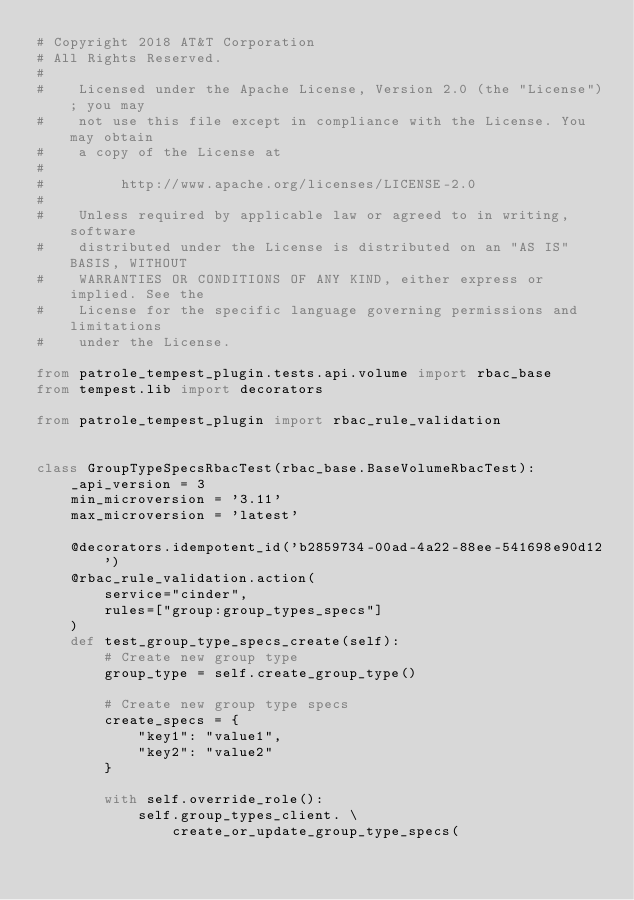Convert code to text. <code><loc_0><loc_0><loc_500><loc_500><_Python_># Copyright 2018 AT&T Corporation
# All Rights Reserved.
#
#    Licensed under the Apache License, Version 2.0 (the "License"); you may
#    not use this file except in compliance with the License. You may obtain
#    a copy of the License at
#
#         http://www.apache.org/licenses/LICENSE-2.0
#
#    Unless required by applicable law or agreed to in writing, software
#    distributed under the License is distributed on an "AS IS" BASIS, WITHOUT
#    WARRANTIES OR CONDITIONS OF ANY KIND, either express or implied. See the
#    License for the specific language governing permissions and limitations
#    under the License.

from patrole_tempest_plugin.tests.api.volume import rbac_base
from tempest.lib import decorators

from patrole_tempest_plugin import rbac_rule_validation


class GroupTypeSpecsRbacTest(rbac_base.BaseVolumeRbacTest):
    _api_version = 3
    min_microversion = '3.11'
    max_microversion = 'latest'

    @decorators.idempotent_id('b2859734-00ad-4a22-88ee-541698e90d12')
    @rbac_rule_validation.action(
        service="cinder",
        rules=["group:group_types_specs"]
    )
    def test_group_type_specs_create(self):
        # Create new group type
        group_type = self.create_group_type()

        # Create new group type specs
        create_specs = {
            "key1": "value1",
            "key2": "value2"
        }

        with self.override_role():
            self.group_types_client. \
                create_or_update_group_type_specs(</code> 